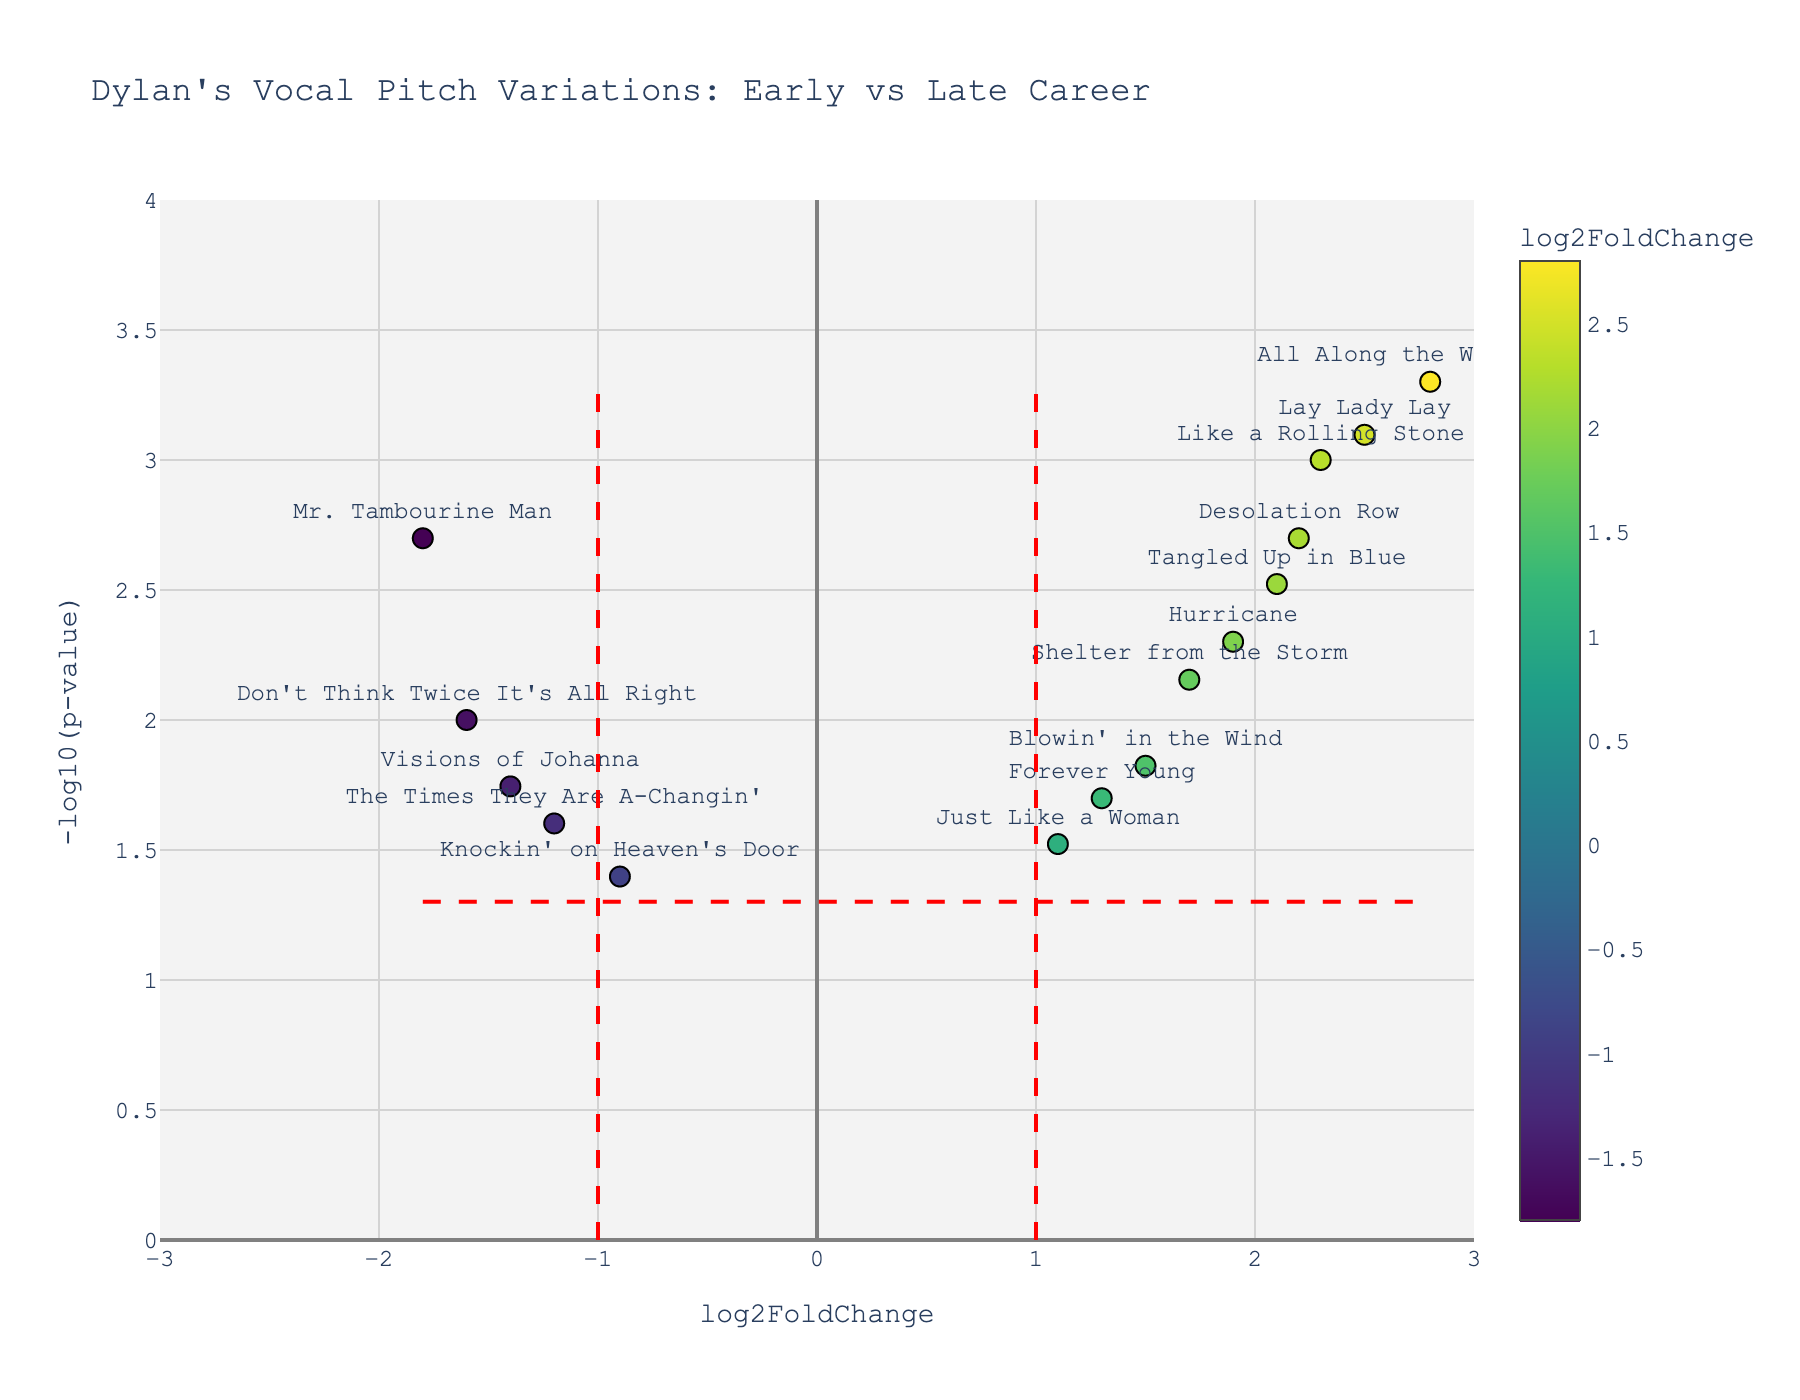What is the title of the Volcano Plot? The title of the plot is located at the top and provides a brief description of the data being visualized. Here, the title is "Dylan's Vocal Pitch Variations: Early vs Late Career".
Answer: Dylan's Vocal Pitch Variations: Early vs Late Career How many songs have a log2FoldChange greater than 2? By observing the x-axis, identify the number of data points to the right of the x=2 line. The songs with log2FoldChange greater than 2 are "Like a Rolling Stone", "Tangled Up in Blue", "Lay Lady Lay", "All Along the Watchtower", and "Desolation Row". There are 5 such songs.
Answer: 5 Which song has the highest -log10(p-value)? Identify the data point that is positioned at the highest vertical position on the y-axis. "All Along the Watchtower" is the song with the highest -log10(p-value).
Answer: All Along the Watchtower What is the significance threshold for p-values in the plot? The plot includes a horizontal dashed red line, which corresponds to the -log10 of the p-value threshold. This line represents -log10(0.05), which is the p-value threshold of 0.05.
Answer: 0.05 Which songs are most strongly associated with Dylan’s early career based on log2FoldChange and p-value? To identify the songs strongly associated with Dylan's early career, look at songs with high absolute values of negative log2FoldChange and significant p-values (high -log10(p-value)). "Mr. Tambourine Man", "The Times They Are A-Changin'", "Knockin' on Heaven's Door", "Don't Think Twice It's All Right", and "Visions of Johanna" fit these criteria.
Answer: Mr. Tambourine Man, The Times They Are A-Changin', Knockin' on Heaven's Door, Don't Think Twice It's All Right, Visions of Johanna Compare the emotional intensity of "Shelter from the Storm" and "Tangled Up in Blue". Locate both songs on the plot and compare their vertical positions (-log10(p-value)) to determine their significance and log2FoldChange values. "Tangled Up in Blue" has higher values for both metrics, indicating greater emotional intensity.
Answer: Tangled Up in Blue What does the color of the data points represent? According to the color scale on the right side of the plot, the color of the data points represents the log2FoldChange values, with varying colors indicating different ranges of these values.
Answer: log2FoldChange Do any songs have a log2FoldChange between -1 and 1 and are significantly different with a p-value < 0.05? Identify songs within the x-axis range of -1 to 1 and above the horizontal dashed line (-log10(0.05) threshold). "Knockin' on Heaven's Door" and "Just Like a Woman" fall into this category.
Answer: Knockin' on Heaven's Door, Just Like a Woman Which song has a log2FoldChange closest to zero but is still significant with a p-value < 0.05? Find the song closest to x=0 on the horizontal axis and above the horizontal red dashed line. "Just Like a Woman" has the log2FoldChange closest to zero and is significant.
Answer: Just Like a Woman 